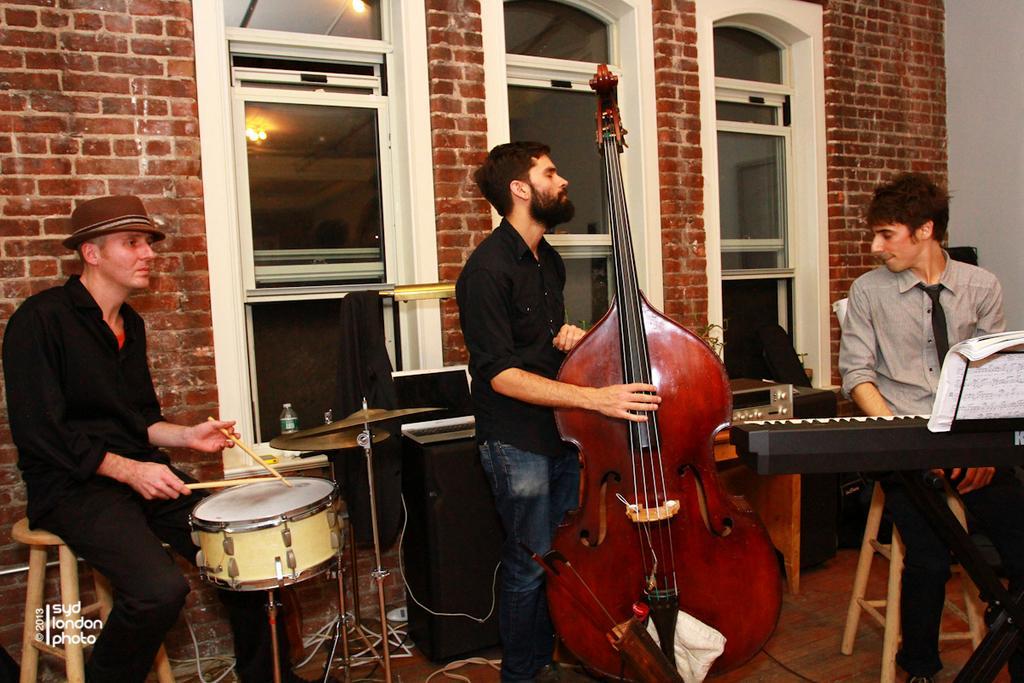Please provide a concise description of this image. On the background of the picture we can see a wall with bricks. These are windows. Here we can see few persons playing musical instruments. This is a floor. And these two persons are sitting. Here we can see water bottle. 